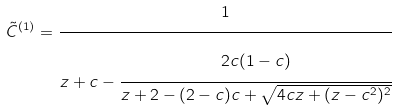Convert formula to latex. <formula><loc_0><loc_0><loc_500><loc_500>\tilde { C } ^ { ( 1 ) } = \cfrac { 1 } { z + c - \cfrac { 2 c ( 1 - c ) } { z + 2 - ( 2 - c ) c + \sqrt { 4 c z + ( z - c ^ { 2 } ) ^ { 2 } } } }</formula> 